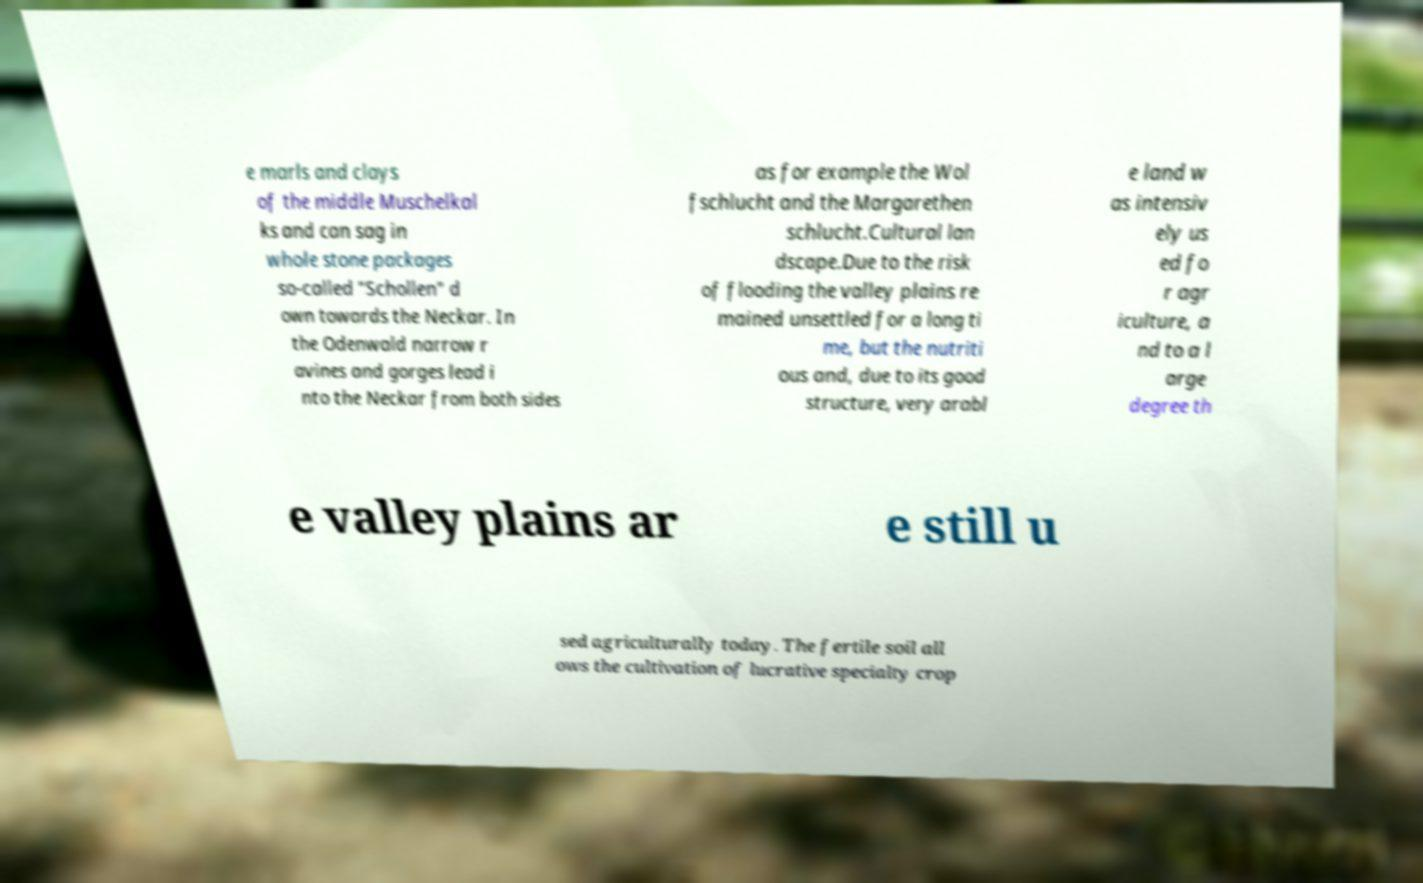Can you read and provide the text displayed in the image?This photo seems to have some interesting text. Can you extract and type it out for me? e marls and clays of the middle Muschelkal ks and can sag in whole stone packages so-called "Schollen" d own towards the Neckar. In the Odenwald narrow r avines and gorges lead i nto the Neckar from both sides as for example the Wol fschlucht and the Margarethen schlucht.Cultural lan dscape.Due to the risk of flooding the valley plains re mained unsettled for a long ti me, but the nutriti ous and, due to its good structure, very arabl e land w as intensiv ely us ed fo r agr iculture, a nd to a l arge degree th e valley plains ar e still u sed agriculturally today. The fertile soil all ows the cultivation of lucrative specialty crop 